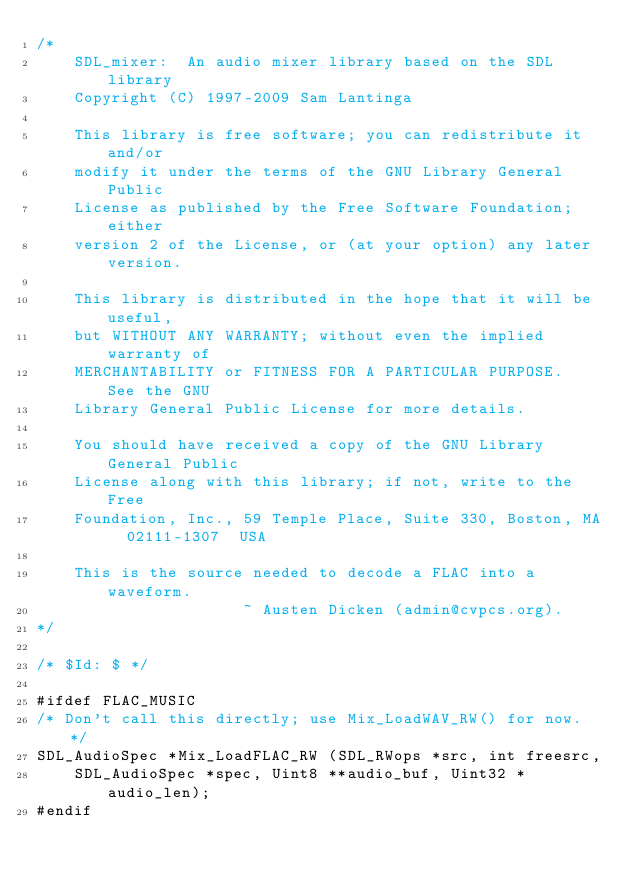Convert code to text. <code><loc_0><loc_0><loc_500><loc_500><_C_>/*
    SDL_mixer:  An audio mixer library based on the SDL library
    Copyright (C) 1997-2009 Sam Lantinga

    This library is free software; you can redistribute it and/or
    modify it under the terms of the GNU Library General Public
    License as published by the Free Software Foundation; either
    version 2 of the License, or (at your option) any later version.

    This library is distributed in the hope that it will be useful,
    but WITHOUT ANY WARRANTY; without even the implied warranty of
    MERCHANTABILITY or FITNESS FOR A PARTICULAR PURPOSE.  See the GNU
    Library General Public License for more details.

    You should have received a copy of the GNU Library General Public
    License along with this library; if not, write to the Free
    Foundation, Inc., 59 Temple Place, Suite 330, Boston, MA  02111-1307  USA

    This is the source needed to decode a FLAC into a waveform.
    									~ Austen Dicken (admin@cvpcs.org).
*/

/* $Id: $ */

#ifdef FLAC_MUSIC
/* Don't call this directly; use Mix_LoadWAV_RW() for now. */
SDL_AudioSpec *Mix_LoadFLAC_RW (SDL_RWops *src, int freesrc,
		SDL_AudioSpec *spec, Uint8 **audio_buf, Uint32 *audio_len);
#endif
</code> 